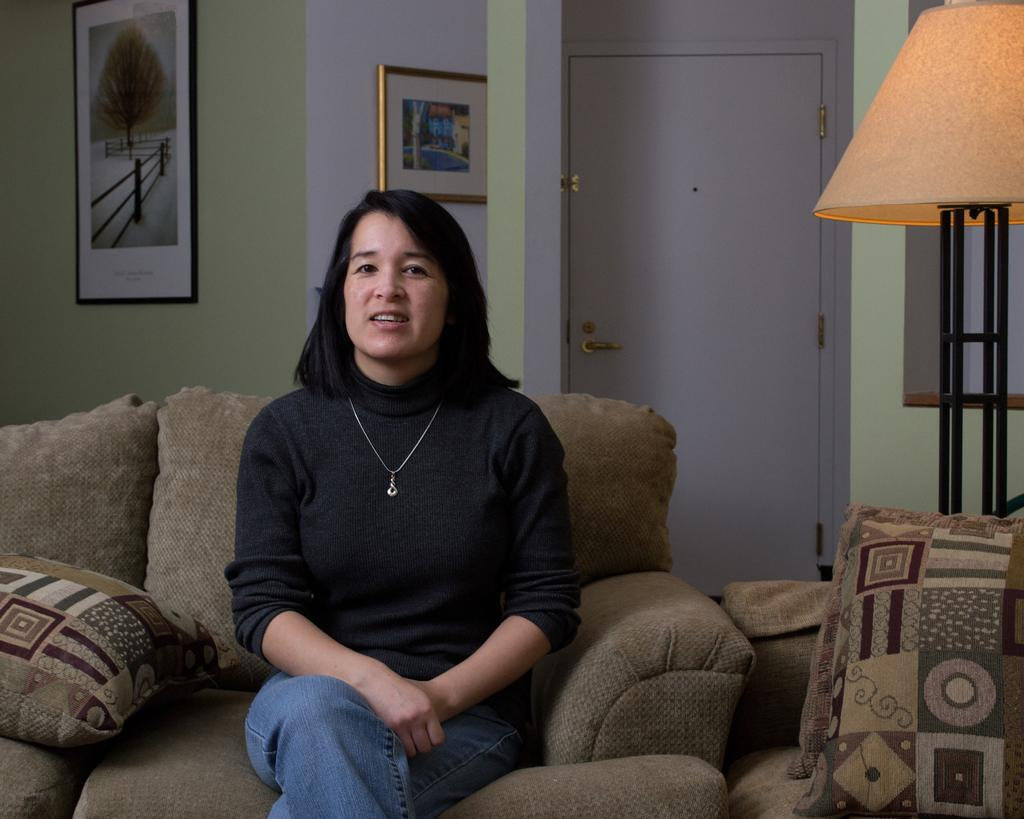What is the woman in the image doing? The woman is sitting on a sofa. Can you describe the background of the image? There is a door visible behind the woman. What type of popcorn is the woman eating in the image? There is no popcorn present in the image. How does the boy in the image interact with the woman? There is no boy present in the image. 